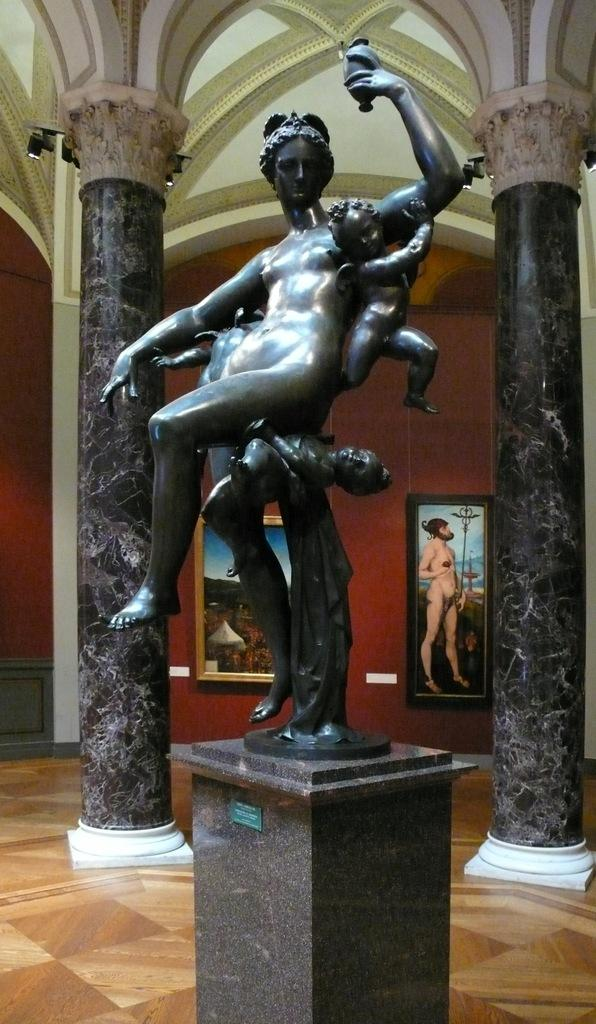What can be seen on the wall in the background of the image? There are frames on the wall in the background. What architectural features are present in the background? There are pillars in the background. What type of artwork is displayed on a pedestal in the image? There are sculptures on a pedestal in the image. What part of the image shows the floor? The floor is visible at the bottom of the image. Is there a ghost visible in the image? No, there is no ghost present in the image. What type of bulb is used to light up the sculptures in the image? There is no mention of a bulb or lighting source in the image; the focus is on the sculptures and their pedestal. 